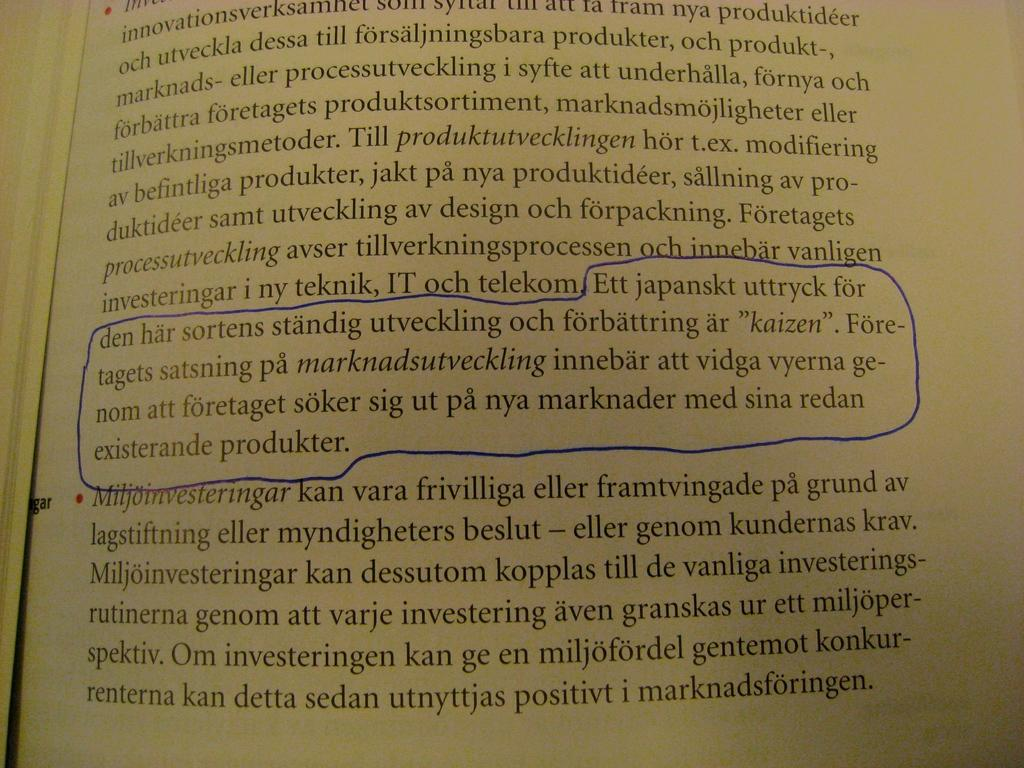<image>
Summarize the visual content of the image. A book is open to a page discussing IT och telekom 